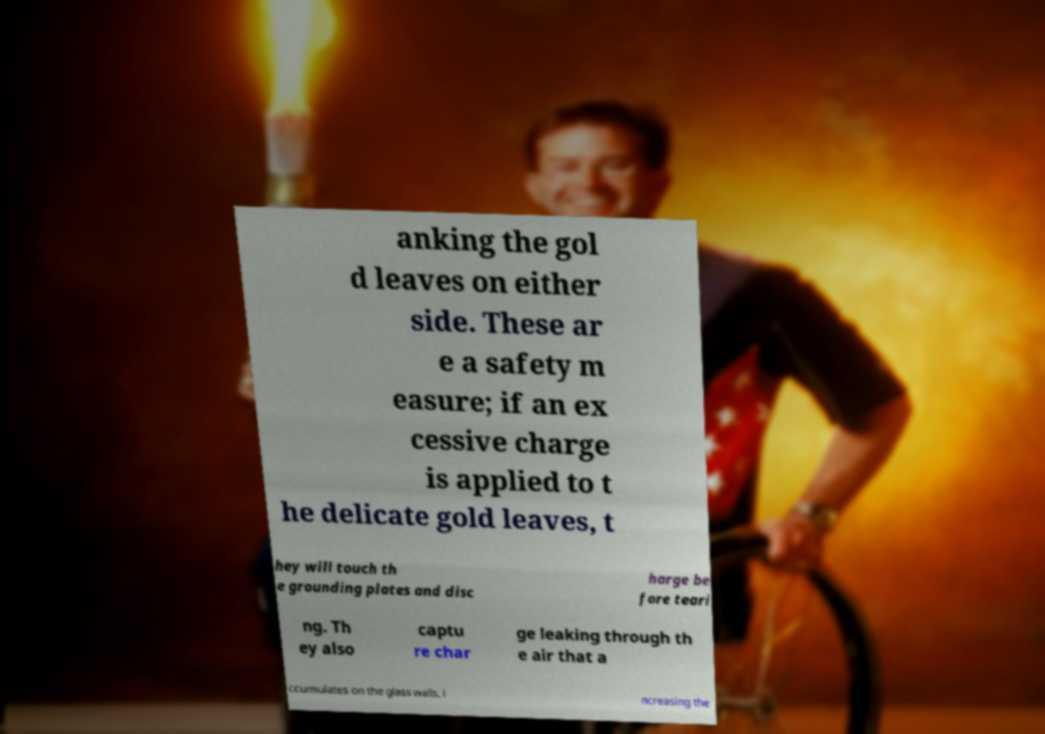There's text embedded in this image that I need extracted. Can you transcribe it verbatim? anking the gol d leaves on either side. These ar e a safety m easure; if an ex cessive charge is applied to t he delicate gold leaves, t hey will touch th e grounding plates and disc harge be fore teari ng. Th ey also captu re char ge leaking through th e air that a ccumulates on the glass walls, i ncreasing the 